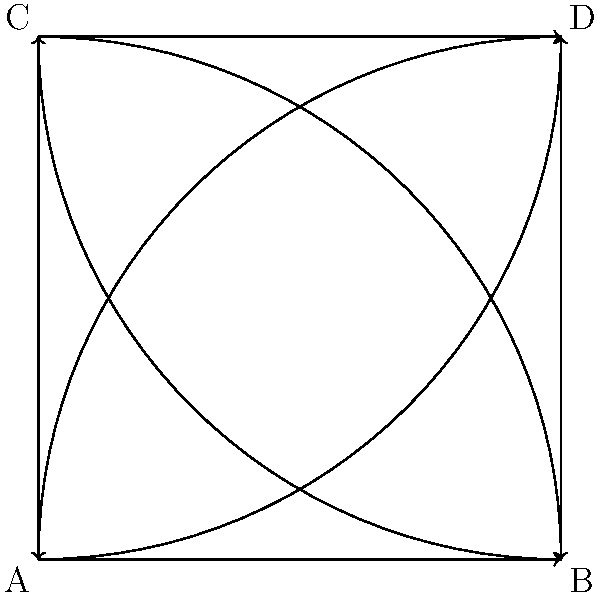In your latest blockbuster, you're filming a high-speed chase scene at a complex highway interchange. Given the traffic flow diagram, how many different paths can a vehicle take to travel from point A to point D without backtracking? Let's break this down step-by-step, considering it as a scene in our movie:

1. First, we need to identify all possible paths from A to D:
   
   a) A → B → D (straight then right)
   b) A → C → D (right then straight)
   c) A → D (direct curved path)

2. Now, let's consider each path as a potential route for our chase scene:

   Path a: This could be a dramatic scene where the pursued car tries to lose the pursuer by taking a longer route.
   Path b: This might be used for a surprise maneuver, cutting off the pursuer unexpectedly.
   Path c: This direct path could be used for a daring, high-speed chase sequence.

3. In cinematographic terms, each of these paths offers a unique visual and narrative possibility, adding depth to our chase scene.

4. From a traffic engineering perspective, this interchange design is known as a "cloverleaf" interchange, popular for its ability to handle high volumes of traffic without the need for traffic lights.

5. The key point is that there are exactly 3 distinct paths from A to D, each offering a different dramatic possibility for our film.
Answer: 3 paths 